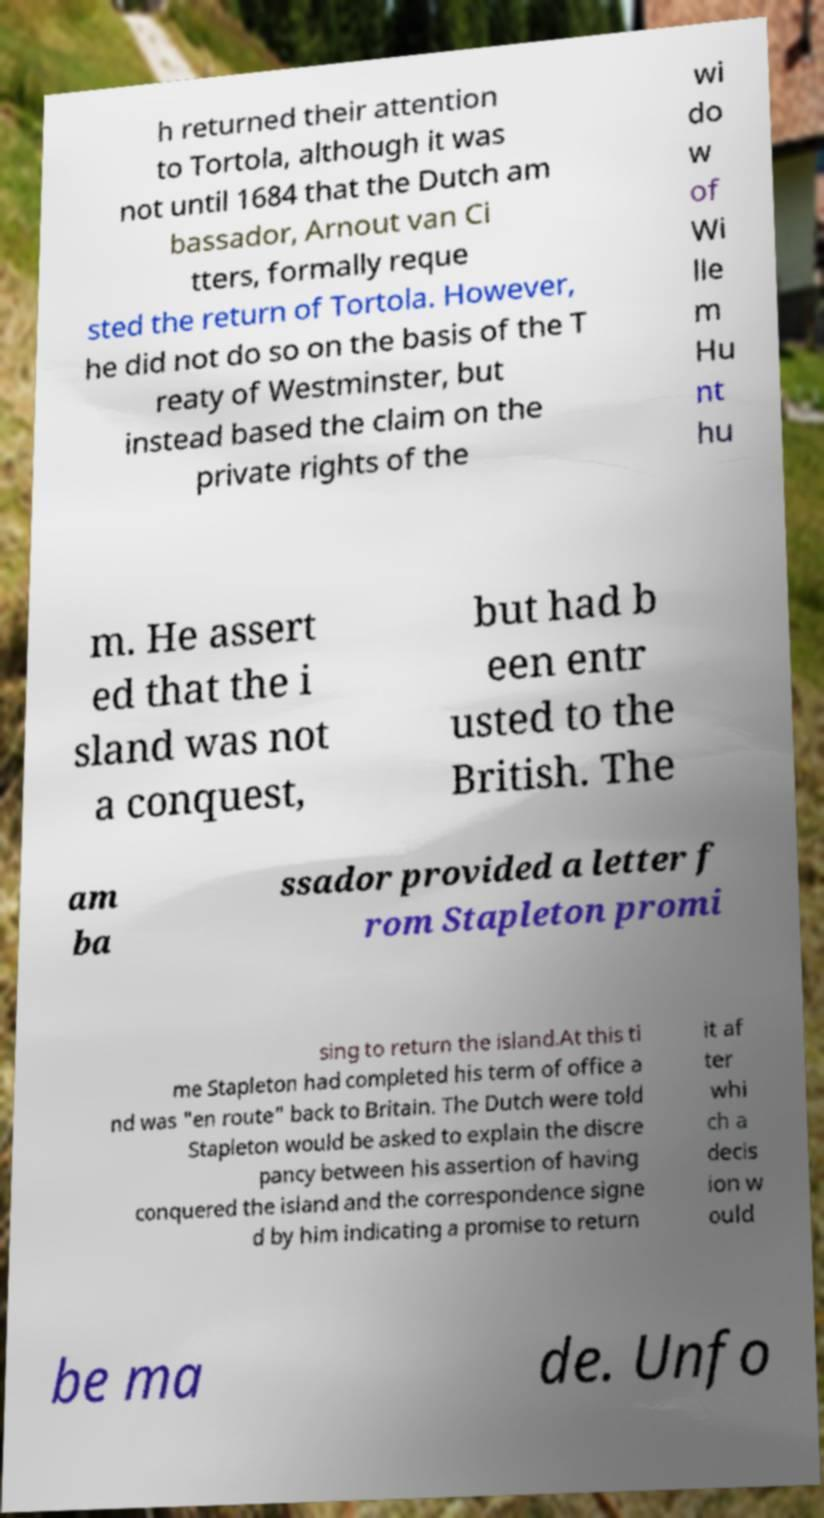Could you assist in decoding the text presented in this image and type it out clearly? h returned their attention to Tortola, although it was not until 1684 that the Dutch am bassador, Arnout van Ci tters, formally reque sted the return of Tortola. However, he did not do so on the basis of the T reaty of Westminster, but instead based the claim on the private rights of the wi do w of Wi lle m Hu nt hu m. He assert ed that the i sland was not a conquest, but had b een entr usted to the British. The am ba ssador provided a letter f rom Stapleton promi sing to return the island.At this ti me Stapleton had completed his term of office a nd was "en route" back to Britain. The Dutch were told Stapleton would be asked to explain the discre pancy between his assertion of having conquered the island and the correspondence signe d by him indicating a promise to return it af ter whi ch a decis ion w ould be ma de. Unfo 